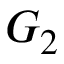<formula> <loc_0><loc_0><loc_500><loc_500>G _ { 2 }</formula> 